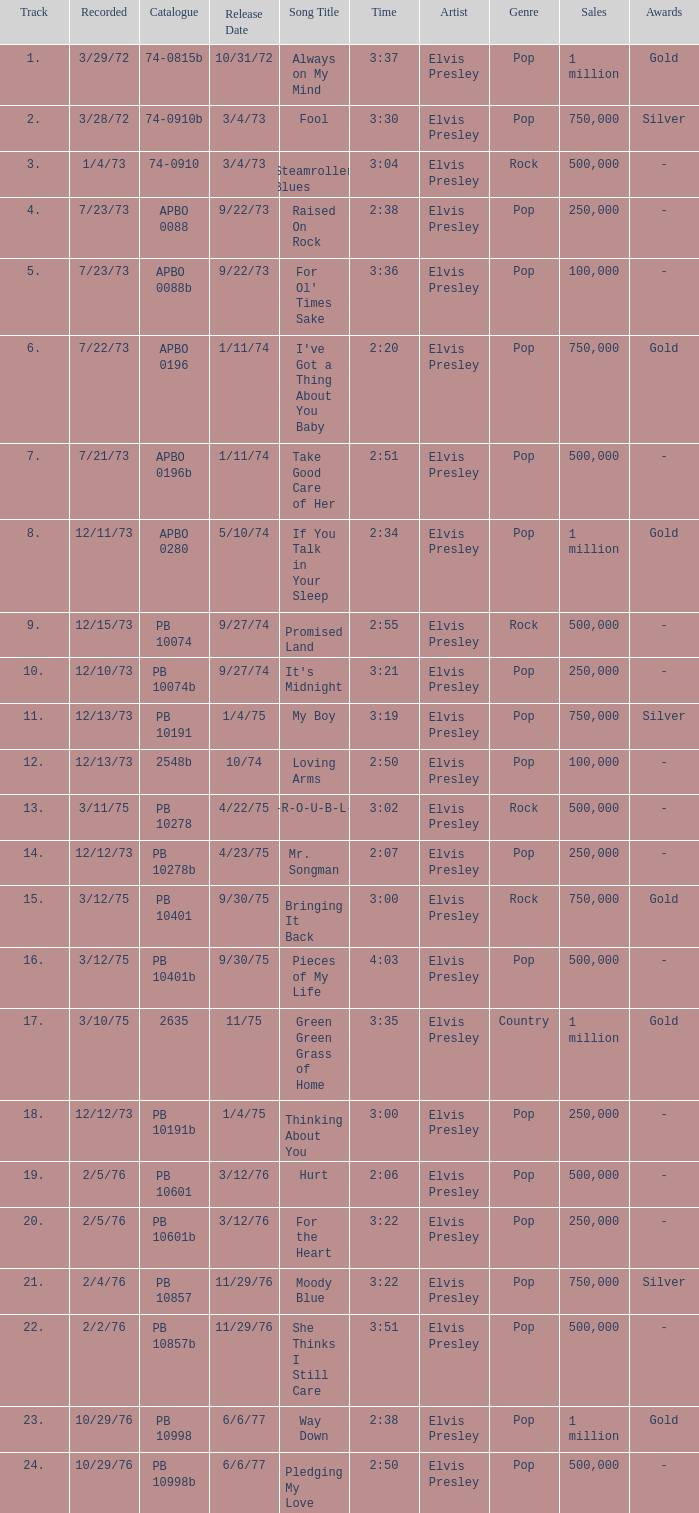Tell me the time for 6/6/77 release date and song title of way down 2:38. 